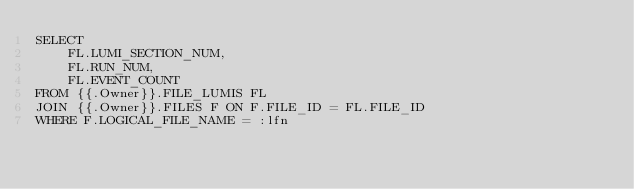<code> <loc_0><loc_0><loc_500><loc_500><_SQL_>SELECT
    FL.LUMI_SECTION_NUM,
    FL.RUN_NUM,
    FL.EVENT_COUNT
FROM {{.Owner}}.FILE_LUMIS FL
JOIN {{.Owner}}.FILES F ON F.FILE_ID = FL.FILE_ID
WHERE F.LOGICAL_FILE_NAME = :lfn
</code> 